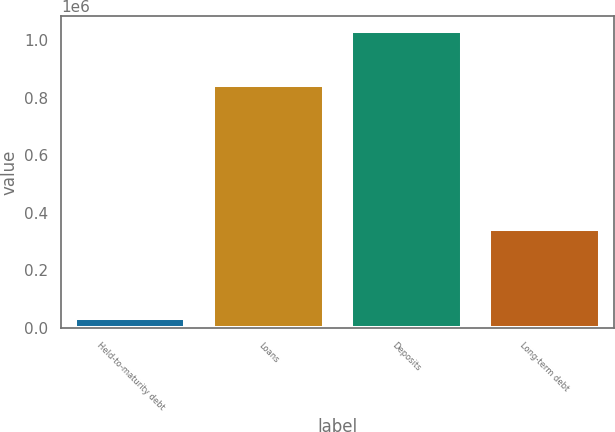<chart> <loc_0><loc_0><loc_500><loc_500><bar_chart><fcel>Held-to-maturity debt<fcel>Loans<fcel>Deposits<fcel>Long-term debt<nl><fcel>35442<fcel>843392<fcel>1.03325e+06<fcel>343211<nl></chart> 